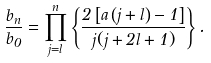<formula> <loc_0><loc_0><loc_500><loc_500>\frac { b _ { n } } { b _ { 0 } } = \prod _ { j = l } ^ { n } \left \{ \frac { 2 \left [ a \left ( j + l \right ) - 1 \right ] } { j ( j + 2 l + 1 ) } \right \} .</formula> 